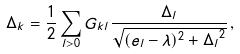<formula> <loc_0><loc_0><loc_500><loc_500>\Delta _ { k } = \frac { 1 } { 2 } \sum _ { l > 0 } G _ { k l } \frac { \Delta _ { l } } { \sqrt { ( e _ { l } - \lambda ) ^ { 2 } + { \Delta _ { l } } ^ { 2 } } } \, ,</formula> 